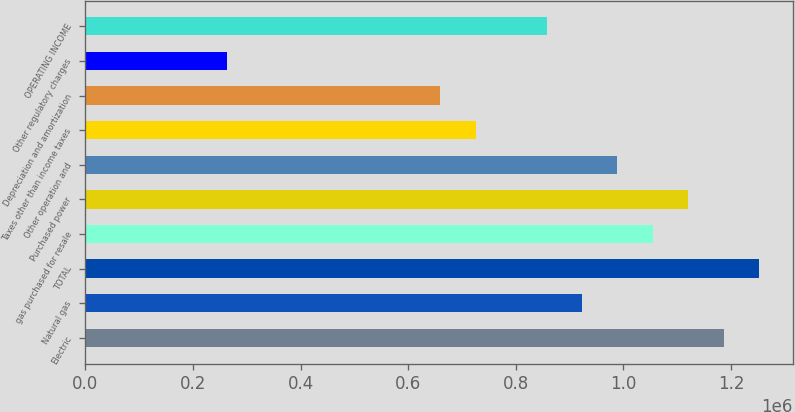Convert chart to OTSL. <chart><loc_0><loc_0><loc_500><loc_500><bar_chart><fcel>Electric<fcel>Natural gas<fcel>TOTAL<fcel>gas purchased for resale<fcel>Purchased power<fcel>Other operation and<fcel>Taxes other than income taxes<fcel>Depreciation and amortization<fcel>Other regulatory charges<fcel>OPERATING INCOME<nl><fcel>1.18675e+06<fcel>923101<fcel>1.25267e+06<fcel>1.05493e+06<fcel>1.12084e+06<fcel>989014<fcel>725362<fcel>659449<fcel>263972<fcel>857188<nl></chart> 